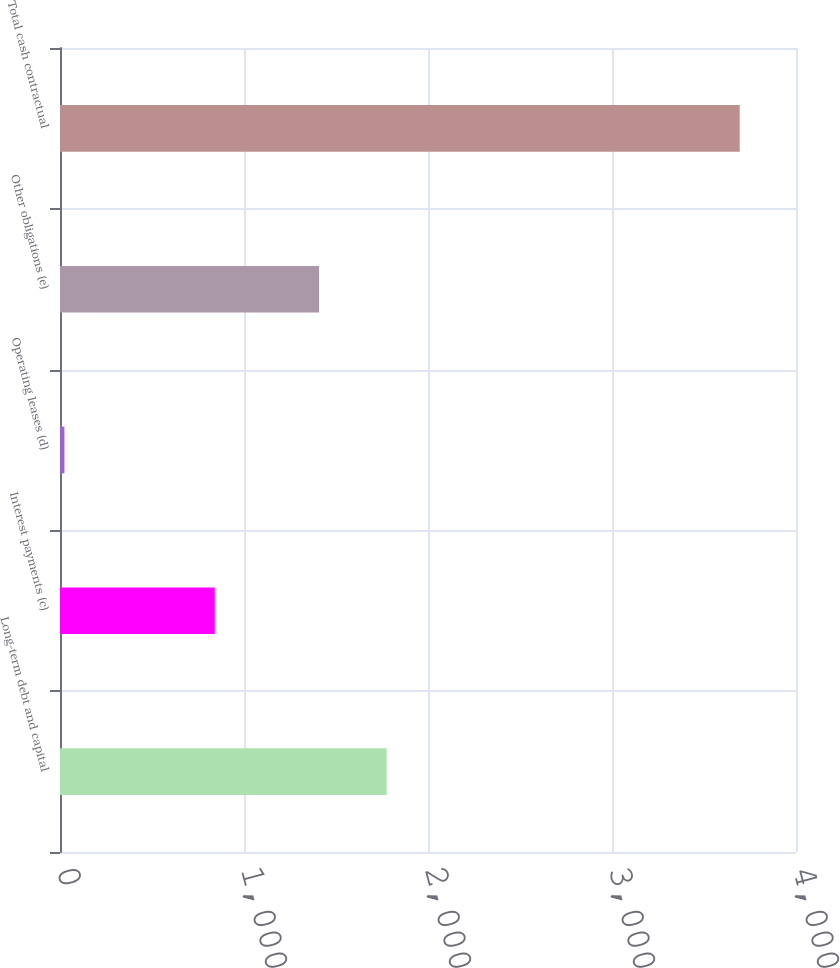Convert chart. <chart><loc_0><loc_0><loc_500><loc_500><bar_chart><fcel>Long-term debt and capital<fcel>Interest payments (c)<fcel>Operating leases (d)<fcel>Other obligations (e)<fcel>Total cash contractual<nl><fcel>1775<fcel>841<fcel>24<fcel>1408<fcel>3694<nl></chart> 